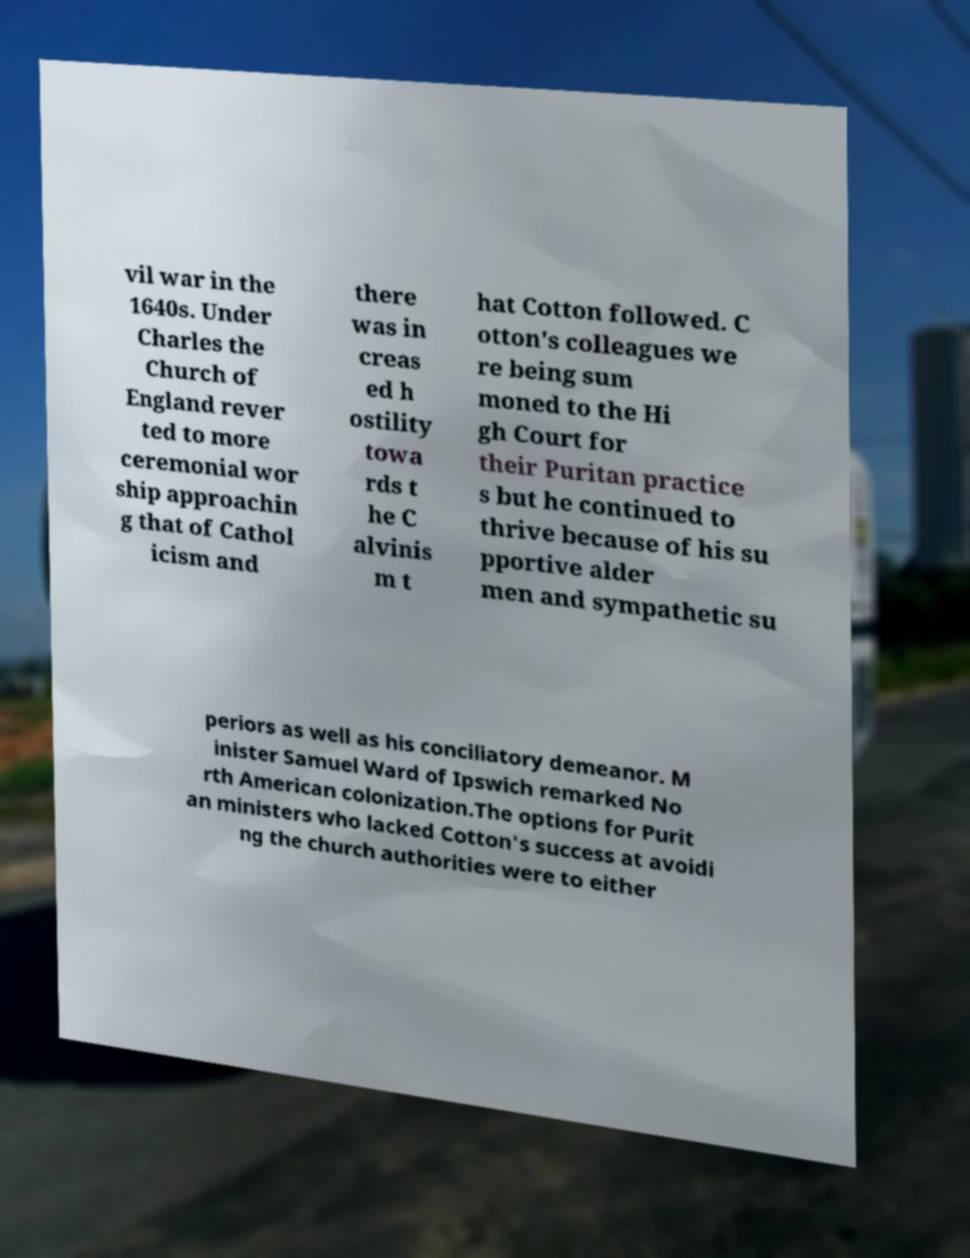Could you assist in decoding the text presented in this image and type it out clearly? vil war in the 1640s. Under Charles the Church of England rever ted to more ceremonial wor ship approachin g that of Cathol icism and there was in creas ed h ostility towa rds t he C alvinis m t hat Cotton followed. C otton's colleagues we re being sum moned to the Hi gh Court for their Puritan practice s but he continued to thrive because of his su pportive alder men and sympathetic su periors as well as his conciliatory demeanor. M inister Samuel Ward of Ipswich remarked No rth American colonization.The options for Purit an ministers who lacked Cotton's success at avoidi ng the church authorities were to either 